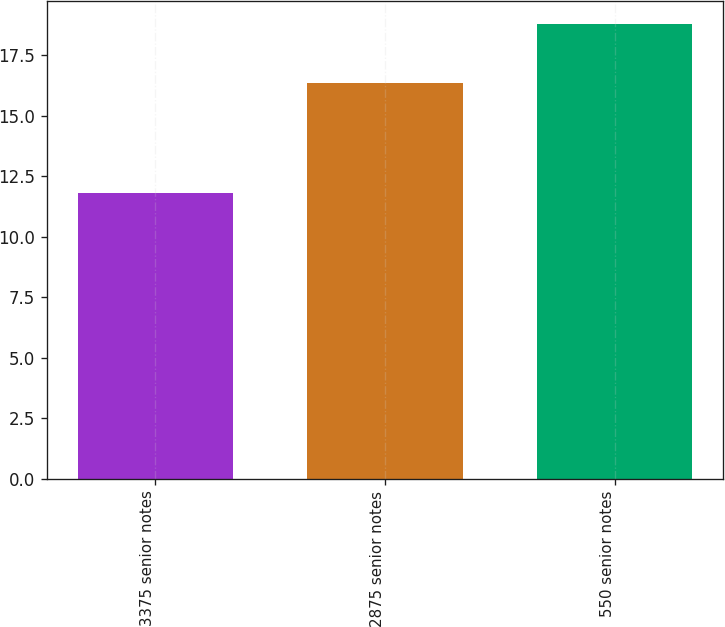Convert chart to OTSL. <chart><loc_0><loc_0><loc_500><loc_500><bar_chart><fcel>3375 senior notes<fcel>2875 senior notes<fcel>550 senior notes<nl><fcel>11.83<fcel>16.35<fcel>18.8<nl></chart> 